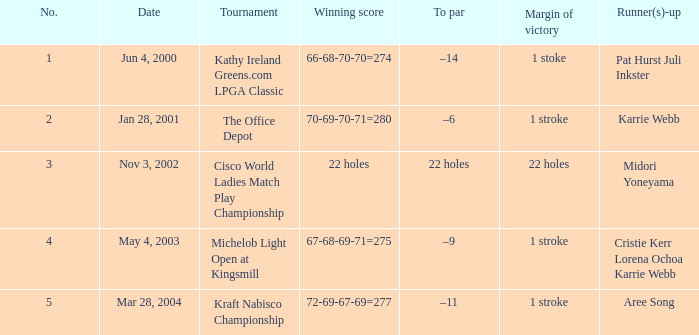Could you help me parse every detail presented in this table? {'header': ['No.', 'Date', 'Tournament', 'Winning score', 'To par', 'Margin of victory', 'Runner(s)-up'], 'rows': [['1', 'Jun 4, 2000', 'Kathy Ireland Greens.com LPGA Classic', '66-68-70-70=274', '–14', '1 stoke', 'Pat Hurst Juli Inkster'], ['2', 'Jan 28, 2001', 'The Office Depot', '70-69-70-71=280', '–6', '1 stroke', 'Karrie Webb'], ['3', 'Nov 3, 2002', 'Cisco World Ladies Match Play Championship', '22 holes', '22 holes', '22 holes', 'Midori Yoneyama'], ['4', 'May 4, 2003', 'Michelob Light Open at Kingsmill', '67-68-69-71=275', '–9', '1 stroke', 'Cristie Kerr Lorena Ochoa Karrie Webb'], ['5', 'Mar 28, 2004', 'Kraft Nabisco Championship', '72-69-67-69=277', '–11', '1 stroke', 'Aree Song']]} Where is the margin of victory dated mar 28, 2004? 1 stroke. 